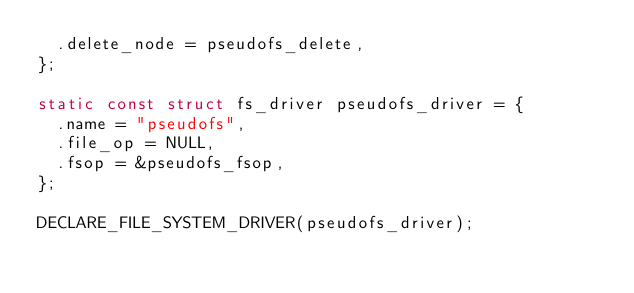Convert code to text. <code><loc_0><loc_0><loc_500><loc_500><_C_>	.delete_node = pseudofs_delete,
};

static const struct fs_driver pseudofs_driver = {
	.name = "pseudofs",
	.file_op = NULL,
	.fsop = &pseudofs_fsop,
};

DECLARE_FILE_SYSTEM_DRIVER(pseudofs_driver);
</code> 